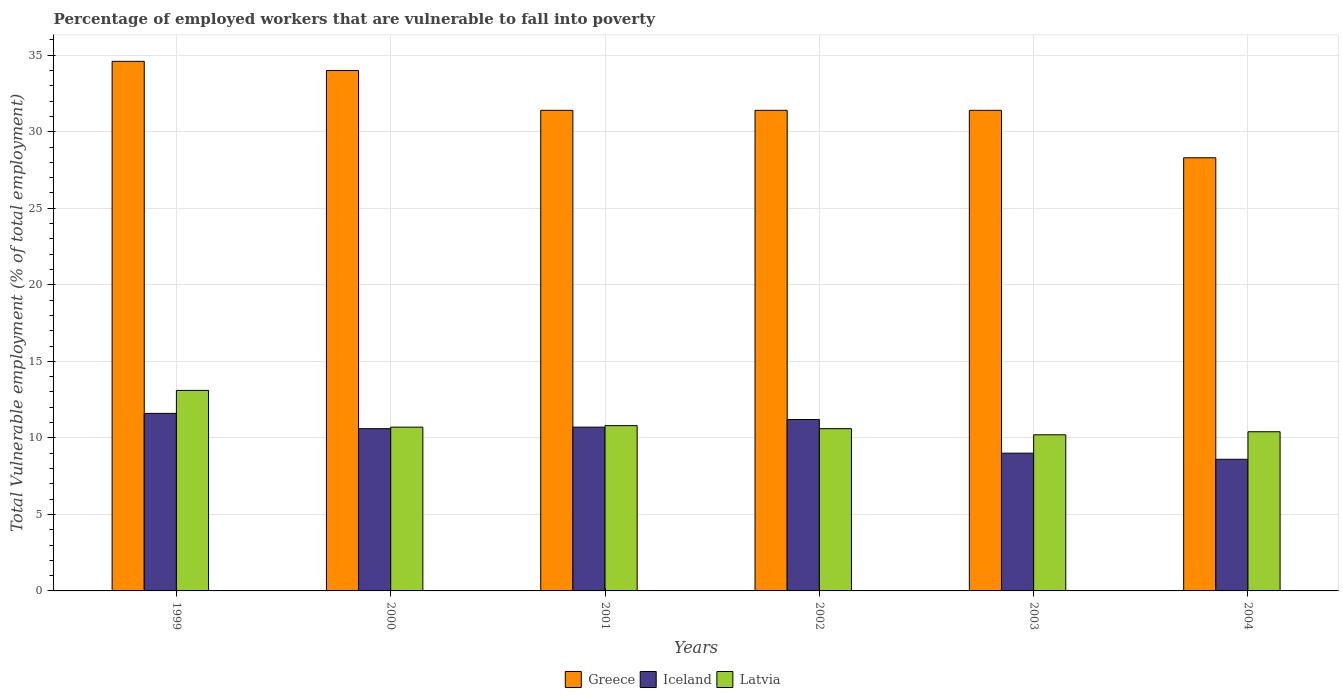How many different coloured bars are there?
Provide a succinct answer. 3. Are the number of bars per tick equal to the number of legend labels?
Ensure brevity in your answer.  Yes. Are the number of bars on each tick of the X-axis equal?
Give a very brief answer. Yes. How many bars are there on the 4th tick from the left?
Ensure brevity in your answer.  3. How many bars are there on the 1st tick from the right?
Your response must be concise. 3. What is the percentage of employed workers who are vulnerable to fall into poverty in Greece in 2001?
Your answer should be very brief. 31.4. Across all years, what is the maximum percentage of employed workers who are vulnerable to fall into poverty in Iceland?
Make the answer very short. 11.6. Across all years, what is the minimum percentage of employed workers who are vulnerable to fall into poverty in Latvia?
Make the answer very short. 10.2. In which year was the percentage of employed workers who are vulnerable to fall into poverty in Latvia maximum?
Provide a short and direct response. 1999. What is the total percentage of employed workers who are vulnerable to fall into poverty in Iceland in the graph?
Ensure brevity in your answer.  61.7. What is the difference between the percentage of employed workers who are vulnerable to fall into poverty in Greece in 2000 and that in 2002?
Your answer should be compact. 2.6. What is the difference between the percentage of employed workers who are vulnerable to fall into poverty in Iceland in 2001 and the percentage of employed workers who are vulnerable to fall into poverty in Latvia in 2004?
Offer a terse response. 0.3. What is the average percentage of employed workers who are vulnerable to fall into poverty in Greece per year?
Your answer should be compact. 31.85. In the year 2002, what is the difference between the percentage of employed workers who are vulnerable to fall into poverty in Latvia and percentage of employed workers who are vulnerable to fall into poverty in Iceland?
Provide a short and direct response. -0.6. What is the ratio of the percentage of employed workers who are vulnerable to fall into poverty in Iceland in 2000 to that in 2004?
Keep it short and to the point. 1.23. Is the percentage of employed workers who are vulnerable to fall into poverty in Greece in 2000 less than that in 2001?
Provide a short and direct response. No. Is the difference between the percentage of employed workers who are vulnerable to fall into poverty in Latvia in 2000 and 2003 greater than the difference between the percentage of employed workers who are vulnerable to fall into poverty in Iceland in 2000 and 2003?
Ensure brevity in your answer.  No. What is the difference between the highest and the second highest percentage of employed workers who are vulnerable to fall into poverty in Greece?
Make the answer very short. 0.6. What is the difference between the highest and the lowest percentage of employed workers who are vulnerable to fall into poverty in Greece?
Make the answer very short. 6.3. In how many years, is the percentage of employed workers who are vulnerable to fall into poverty in Greece greater than the average percentage of employed workers who are vulnerable to fall into poverty in Greece taken over all years?
Ensure brevity in your answer.  2. What does the 1st bar from the right in 2004 represents?
Ensure brevity in your answer.  Latvia. Is it the case that in every year, the sum of the percentage of employed workers who are vulnerable to fall into poverty in Latvia and percentage of employed workers who are vulnerable to fall into poverty in Greece is greater than the percentage of employed workers who are vulnerable to fall into poverty in Iceland?
Provide a short and direct response. Yes. What is the difference between two consecutive major ticks on the Y-axis?
Make the answer very short. 5. Does the graph contain grids?
Your answer should be very brief. Yes. What is the title of the graph?
Ensure brevity in your answer.  Percentage of employed workers that are vulnerable to fall into poverty. Does "Croatia" appear as one of the legend labels in the graph?
Your answer should be very brief. No. What is the label or title of the X-axis?
Provide a short and direct response. Years. What is the label or title of the Y-axis?
Provide a short and direct response. Total Vulnerable employment (% of total employment). What is the Total Vulnerable employment (% of total employment) of Greece in 1999?
Offer a terse response. 34.6. What is the Total Vulnerable employment (% of total employment) in Iceland in 1999?
Your answer should be compact. 11.6. What is the Total Vulnerable employment (% of total employment) of Latvia in 1999?
Your answer should be very brief. 13.1. What is the Total Vulnerable employment (% of total employment) in Iceland in 2000?
Your answer should be very brief. 10.6. What is the Total Vulnerable employment (% of total employment) of Latvia in 2000?
Provide a short and direct response. 10.7. What is the Total Vulnerable employment (% of total employment) of Greece in 2001?
Ensure brevity in your answer.  31.4. What is the Total Vulnerable employment (% of total employment) in Iceland in 2001?
Your answer should be compact. 10.7. What is the Total Vulnerable employment (% of total employment) in Latvia in 2001?
Ensure brevity in your answer.  10.8. What is the Total Vulnerable employment (% of total employment) of Greece in 2002?
Provide a short and direct response. 31.4. What is the Total Vulnerable employment (% of total employment) of Iceland in 2002?
Your response must be concise. 11.2. What is the Total Vulnerable employment (% of total employment) in Latvia in 2002?
Your response must be concise. 10.6. What is the Total Vulnerable employment (% of total employment) in Greece in 2003?
Keep it short and to the point. 31.4. What is the Total Vulnerable employment (% of total employment) in Latvia in 2003?
Provide a succinct answer. 10.2. What is the Total Vulnerable employment (% of total employment) in Greece in 2004?
Your answer should be compact. 28.3. What is the Total Vulnerable employment (% of total employment) in Iceland in 2004?
Your answer should be compact. 8.6. What is the Total Vulnerable employment (% of total employment) of Latvia in 2004?
Your answer should be compact. 10.4. Across all years, what is the maximum Total Vulnerable employment (% of total employment) in Greece?
Your answer should be very brief. 34.6. Across all years, what is the maximum Total Vulnerable employment (% of total employment) in Iceland?
Offer a terse response. 11.6. Across all years, what is the maximum Total Vulnerable employment (% of total employment) of Latvia?
Your answer should be compact. 13.1. Across all years, what is the minimum Total Vulnerable employment (% of total employment) in Greece?
Ensure brevity in your answer.  28.3. Across all years, what is the minimum Total Vulnerable employment (% of total employment) of Iceland?
Provide a succinct answer. 8.6. Across all years, what is the minimum Total Vulnerable employment (% of total employment) in Latvia?
Offer a terse response. 10.2. What is the total Total Vulnerable employment (% of total employment) in Greece in the graph?
Your answer should be very brief. 191.1. What is the total Total Vulnerable employment (% of total employment) of Iceland in the graph?
Keep it short and to the point. 61.7. What is the total Total Vulnerable employment (% of total employment) of Latvia in the graph?
Offer a terse response. 65.8. What is the difference between the Total Vulnerable employment (% of total employment) in Iceland in 1999 and that in 2000?
Offer a terse response. 1. What is the difference between the Total Vulnerable employment (% of total employment) in Latvia in 1999 and that in 2000?
Your response must be concise. 2.4. What is the difference between the Total Vulnerable employment (% of total employment) of Greece in 1999 and that in 2002?
Provide a succinct answer. 3.2. What is the difference between the Total Vulnerable employment (% of total employment) in Iceland in 1999 and that in 2002?
Offer a terse response. 0.4. What is the difference between the Total Vulnerable employment (% of total employment) of Iceland in 1999 and that in 2003?
Offer a very short reply. 2.6. What is the difference between the Total Vulnerable employment (% of total employment) in Greece in 1999 and that in 2004?
Provide a succinct answer. 6.3. What is the difference between the Total Vulnerable employment (% of total employment) of Iceland in 1999 and that in 2004?
Make the answer very short. 3. What is the difference between the Total Vulnerable employment (% of total employment) in Greece in 2000 and that in 2001?
Offer a very short reply. 2.6. What is the difference between the Total Vulnerable employment (% of total employment) in Greece in 2000 and that in 2002?
Offer a very short reply. 2.6. What is the difference between the Total Vulnerable employment (% of total employment) of Iceland in 2000 and that in 2002?
Make the answer very short. -0.6. What is the difference between the Total Vulnerable employment (% of total employment) of Latvia in 2000 and that in 2002?
Keep it short and to the point. 0.1. What is the difference between the Total Vulnerable employment (% of total employment) of Greece in 2000 and that in 2003?
Your answer should be very brief. 2.6. What is the difference between the Total Vulnerable employment (% of total employment) in Iceland in 2000 and that in 2003?
Provide a short and direct response. 1.6. What is the difference between the Total Vulnerable employment (% of total employment) in Latvia in 2000 and that in 2003?
Make the answer very short. 0.5. What is the difference between the Total Vulnerable employment (% of total employment) in Greece in 2001 and that in 2002?
Keep it short and to the point. 0. What is the difference between the Total Vulnerable employment (% of total employment) of Iceland in 2001 and that in 2002?
Offer a terse response. -0.5. What is the difference between the Total Vulnerable employment (% of total employment) of Greece in 2001 and that in 2003?
Provide a succinct answer. 0. What is the difference between the Total Vulnerable employment (% of total employment) of Iceland in 2001 and that in 2003?
Your response must be concise. 1.7. What is the difference between the Total Vulnerable employment (% of total employment) in Latvia in 2001 and that in 2003?
Your answer should be compact. 0.6. What is the difference between the Total Vulnerable employment (% of total employment) of Greece in 2001 and that in 2004?
Give a very brief answer. 3.1. What is the difference between the Total Vulnerable employment (% of total employment) of Iceland in 2001 and that in 2004?
Ensure brevity in your answer.  2.1. What is the difference between the Total Vulnerable employment (% of total employment) in Greece in 2002 and that in 2003?
Offer a very short reply. 0. What is the difference between the Total Vulnerable employment (% of total employment) of Iceland in 2002 and that in 2003?
Offer a terse response. 2.2. What is the difference between the Total Vulnerable employment (% of total employment) in Latvia in 2002 and that in 2003?
Give a very brief answer. 0.4. What is the difference between the Total Vulnerable employment (% of total employment) in Greece in 2002 and that in 2004?
Provide a short and direct response. 3.1. What is the difference between the Total Vulnerable employment (% of total employment) of Iceland in 2002 and that in 2004?
Provide a succinct answer. 2.6. What is the difference between the Total Vulnerable employment (% of total employment) of Latvia in 2002 and that in 2004?
Your response must be concise. 0.2. What is the difference between the Total Vulnerable employment (% of total employment) of Iceland in 2003 and that in 2004?
Provide a succinct answer. 0.4. What is the difference between the Total Vulnerable employment (% of total employment) in Latvia in 2003 and that in 2004?
Your response must be concise. -0.2. What is the difference between the Total Vulnerable employment (% of total employment) of Greece in 1999 and the Total Vulnerable employment (% of total employment) of Latvia in 2000?
Offer a terse response. 23.9. What is the difference between the Total Vulnerable employment (% of total employment) of Greece in 1999 and the Total Vulnerable employment (% of total employment) of Iceland in 2001?
Keep it short and to the point. 23.9. What is the difference between the Total Vulnerable employment (% of total employment) in Greece in 1999 and the Total Vulnerable employment (% of total employment) in Latvia in 2001?
Keep it short and to the point. 23.8. What is the difference between the Total Vulnerable employment (% of total employment) in Iceland in 1999 and the Total Vulnerable employment (% of total employment) in Latvia in 2001?
Give a very brief answer. 0.8. What is the difference between the Total Vulnerable employment (% of total employment) in Greece in 1999 and the Total Vulnerable employment (% of total employment) in Iceland in 2002?
Provide a succinct answer. 23.4. What is the difference between the Total Vulnerable employment (% of total employment) in Greece in 1999 and the Total Vulnerable employment (% of total employment) in Latvia in 2002?
Provide a short and direct response. 24. What is the difference between the Total Vulnerable employment (% of total employment) in Greece in 1999 and the Total Vulnerable employment (% of total employment) in Iceland in 2003?
Provide a short and direct response. 25.6. What is the difference between the Total Vulnerable employment (% of total employment) of Greece in 1999 and the Total Vulnerable employment (% of total employment) of Latvia in 2003?
Offer a terse response. 24.4. What is the difference between the Total Vulnerable employment (% of total employment) in Iceland in 1999 and the Total Vulnerable employment (% of total employment) in Latvia in 2003?
Give a very brief answer. 1.4. What is the difference between the Total Vulnerable employment (% of total employment) in Greece in 1999 and the Total Vulnerable employment (% of total employment) in Iceland in 2004?
Your answer should be very brief. 26. What is the difference between the Total Vulnerable employment (% of total employment) in Greece in 1999 and the Total Vulnerable employment (% of total employment) in Latvia in 2004?
Your answer should be very brief. 24.2. What is the difference between the Total Vulnerable employment (% of total employment) in Greece in 2000 and the Total Vulnerable employment (% of total employment) in Iceland in 2001?
Make the answer very short. 23.3. What is the difference between the Total Vulnerable employment (% of total employment) in Greece in 2000 and the Total Vulnerable employment (% of total employment) in Latvia in 2001?
Your answer should be very brief. 23.2. What is the difference between the Total Vulnerable employment (% of total employment) in Iceland in 2000 and the Total Vulnerable employment (% of total employment) in Latvia in 2001?
Your answer should be very brief. -0.2. What is the difference between the Total Vulnerable employment (% of total employment) in Greece in 2000 and the Total Vulnerable employment (% of total employment) in Iceland in 2002?
Offer a very short reply. 22.8. What is the difference between the Total Vulnerable employment (% of total employment) in Greece in 2000 and the Total Vulnerable employment (% of total employment) in Latvia in 2002?
Keep it short and to the point. 23.4. What is the difference between the Total Vulnerable employment (% of total employment) in Greece in 2000 and the Total Vulnerable employment (% of total employment) in Latvia in 2003?
Provide a short and direct response. 23.8. What is the difference between the Total Vulnerable employment (% of total employment) of Iceland in 2000 and the Total Vulnerable employment (% of total employment) of Latvia in 2003?
Offer a very short reply. 0.4. What is the difference between the Total Vulnerable employment (% of total employment) of Greece in 2000 and the Total Vulnerable employment (% of total employment) of Iceland in 2004?
Your answer should be very brief. 25.4. What is the difference between the Total Vulnerable employment (% of total employment) of Greece in 2000 and the Total Vulnerable employment (% of total employment) of Latvia in 2004?
Keep it short and to the point. 23.6. What is the difference between the Total Vulnerable employment (% of total employment) of Iceland in 2000 and the Total Vulnerable employment (% of total employment) of Latvia in 2004?
Ensure brevity in your answer.  0.2. What is the difference between the Total Vulnerable employment (% of total employment) in Greece in 2001 and the Total Vulnerable employment (% of total employment) in Iceland in 2002?
Your answer should be compact. 20.2. What is the difference between the Total Vulnerable employment (% of total employment) of Greece in 2001 and the Total Vulnerable employment (% of total employment) of Latvia in 2002?
Offer a terse response. 20.8. What is the difference between the Total Vulnerable employment (% of total employment) in Greece in 2001 and the Total Vulnerable employment (% of total employment) in Iceland in 2003?
Provide a short and direct response. 22.4. What is the difference between the Total Vulnerable employment (% of total employment) in Greece in 2001 and the Total Vulnerable employment (% of total employment) in Latvia in 2003?
Your answer should be very brief. 21.2. What is the difference between the Total Vulnerable employment (% of total employment) of Iceland in 2001 and the Total Vulnerable employment (% of total employment) of Latvia in 2003?
Provide a short and direct response. 0.5. What is the difference between the Total Vulnerable employment (% of total employment) in Greece in 2001 and the Total Vulnerable employment (% of total employment) in Iceland in 2004?
Provide a succinct answer. 22.8. What is the difference between the Total Vulnerable employment (% of total employment) of Greece in 2002 and the Total Vulnerable employment (% of total employment) of Iceland in 2003?
Your response must be concise. 22.4. What is the difference between the Total Vulnerable employment (% of total employment) of Greece in 2002 and the Total Vulnerable employment (% of total employment) of Latvia in 2003?
Provide a short and direct response. 21.2. What is the difference between the Total Vulnerable employment (% of total employment) of Greece in 2002 and the Total Vulnerable employment (% of total employment) of Iceland in 2004?
Your answer should be compact. 22.8. What is the difference between the Total Vulnerable employment (% of total employment) of Greece in 2002 and the Total Vulnerable employment (% of total employment) of Latvia in 2004?
Keep it short and to the point. 21. What is the difference between the Total Vulnerable employment (% of total employment) of Iceland in 2002 and the Total Vulnerable employment (% of total employment) of Latvia in 2004?
Your answer should be very brief. 0.8. What is the difference between the Total Vulnerable employment (% of total employment) of Greece in 2003 and the Total Vulnerable employment (% of total employment) of Iceland in 2004?
Provide a short and direct response. 22.8. What is the difference between the Total Vulnerable employment (% of total employment) in Greece in 2003 and the Total Vulnerable employment (% of total employment) in Latvia in 2004?
Offer a very short reply. 21. What is the difference between the Total Vulnerable employment (% of total employment) of Iceland in 2003 and the Total Vulnerable employment (% of total employment) of Latvia in 2004?
Offer a very short reply. -1.4. What is the average Total Vulnerable employment (% of total employment) of Greece per year?
Offer a terse response. 31.85. What is the average Total Vulnerable employment (% of total employment) in Iceland per year?
Provide a succinct answer. 10.28. What is the average Total Vulnerable employment (% of total employment) of Latvia per year?
Make the answer very short. 10.97. In the year 1999, what is the difference between the Total Vulnerable employment (% of total employment) in Greece and Total Vulnerable employment (% of total employment) in Latvia?
Keep it short and to the point. 21.5. In the year 1999, what is the difference between the Total Vulnerable employment (% of total employment) in Iceland and Total Vulnerable employment (% of total employment) in Latvia?
Offer a very short reply. -1.5. In the year 2000, what is the difference between the Total Vulnerable employment (% of total employment) of Greece and Total Vulnerable employment (% of total employment) of Iceland?
Your answer should be compact. 23.4. In the year 2000, what is the difference between the Total Vulnerable employment (% of total employment) in Greece and Total Vulnerable employment (% of total employment) in Latvia?
Your answer should be very brief. 23.3. In the year 2001, what is the difference between the Total Vulnerable employment (% of total employment) in Greece and Total Vulnerable employment (% of total employment) in Iceland?
Make the answer very short. 20.7. In the year 2001, what is the difference between the Total Vulnerable employment (% of total employment) of Greece and Total Vulnerable employment (% of total employment) of Latvia?
Your answer should be very brief. 20.6. In the year 2001, what is the difference between the Total Vulnerable employment (% of total employment) of Iceland and Total Vulnerable employment (% of total employment) of Latvia?
Provide a succinct answer. -0.1. In the year 2002, what is the difference between the Total Vulnerable employment (% of total employment) in Greece and Total Vulnerable employment (% of total employment) in Iceland?
Provide a short and direct response. 20.2. In the year 2002, what is the difference between the Total Vulnerable employment (% of total employment) of Greece and Total Vulnerable employment (% of total employment) of Latvia?
Offer a terse response. 20.8. In the year 2003, what is the difference between the Total Vulnerable employment (% of total employment) of Greece and Total Vulnerable employment (% of total employment) of Iceland?
Make the answer very short. 22.4. In the year 2003, what is the difference between the Total Vulnerable employment (% of total employment) in Greece and Total Vulnerable employment (% of total employment) in Latvia?
Offer a terse response. 21.2. In the year 2003, what is the difference between the Total Vulnerable employment (% of total employment) in Iceland and Total Vulnerable employment (% of total employment) in Latvia?
Your answer should be compact. -1.2. In the year 2004, what is the difference between the Total Vulnerable employment (% of total employment) in Greece and Total Vulnerable employment (% of total employment) in Iceland?
Offer a very short reply. 19.7. In the year 2004, what is the difference between the Total Vulnerable employment (% of total employment) in Greece and Total Vulnerable employment (% of total employment) in Latvia?
Your answer should be very brief. 17.9. In the year 2004, what is the difference between the Total Vulnerable employment (% of total employment) in Iceland and Total Vulnerable employment (% of total employment) in Latvia?
Offer a terse response. -1.8. What is the ratio of the Total Vulnerable employment (% of total employment) in Greece in 1999 to that in 2000?
Your answer should be very brief. 1.02. What is the ratio of the Total Vulnerable employment (% of total employment) in Iceland in 1999 to that in 2000?
Ensure brevity in your answer.  1.09. What is the ratio of the Total Vulnerable employment (% of total employment) of Latvia in 1999 to that in 2000?
Your answer should be very brief. 1.22. What is the ratio of the Total Vulnerable employment (% of total employment) in Greece in 1999 to that in 2001?
Offer a terse response. 1.1. What is the ratio of the Total Vulnerable employment (% of total employment) of Iceland in 1999 to that in 2001?
Offer a very short reply. 1.08. What is the ratio of the Total Vulnerable employment (% of total employment) of Latvia in 1999 to that in 2001?
Give a very brief answer. 1.21. What is the ratio of the Total Vulnerable employment (% of total employment) of Greece in 1999 to that in 2002?
Keep it short and to the point. 1.1. What is the ratio of the Total Vulnerable employment (% of total employment) of Iceland in 1999 to that in 2002?
Keep it short and to the point. 1.04. What is the ratio of the Total Vulnerable employment (% of total employment) of Latvia in 1999 to that in 2002?
Your answer should be very brief. 1.24. What is the ratio of the Total Vulnerable employment (% of total employment) of Greece in 1999 to that in 2003?
Offer a very short reply. 1.1. What is the ratio of the Total Vulnerable employment (% of total employment) in Iceland in 1999 to that in 2003?
Your answer should be compact. 1.29. What is the ratio of the Total Vulnerable employment (% of total employment) in Latvia in 1999 to that in 2003?
Your answer should be very brief. 1.28. What is the ratio of the Total Vulnerable employment (% of total employment) in Greece in 1999 to that in 2004?
Your response must be concise. 1.22. What is the ratio of the Total Vulnerable employment (% of total employment) of Iceland in 1999 to that in 2004?
Keep it short and to the point. 1.35. What is the ratio of the Total Vulnerable employment (% of total employment) of Latvia in 1999 to that in 2004?
Your answer should be very brief. 1.26. What is the ratio of the Total Vulnerable employment (% of total employment) of Greece in 2000 to that in 2001?
Your answer should be very brief. 1.08. What is the ratio of the Total Vulnerable employment (% of total employment) of Greece in 2000 to that in 2002?
Give a very brief answer. 1.08. What is the ratio of the Total Vulnerable employment (% of total employment) of Iceland in 2000 to that in 2002?
Offer a very short reply. 0.95. What is the ratio of the Total Vulnerable employment (% of total employment) of Latvia in 2000 to that in 2002?
Your answer should be compact. 1.01. What is the ratio of the Total Vulnerable employment (% of total employment) of Greece in 2000 to that in 2003?
Provide a short and direct response. 1.08. What is the ratio of the Total Vulnerable employment (% of total employment) of Iceland in 2000 to that in 2003?
Offer a very short reply. 1.18. What is the ratio of the Total Vulnerable employment (% of total employment) in Latvia in 2000 to that in 2003?
Provide a succinct answer. 1.05. What is the ratio of the Total Vulnerable employment (% of total employment) of Greece in 2000 to that in 2004?
Provide a succinct answer. 1.2. What is the ratio of the Total Vulnerable employment (% of total employment) in Iceland in 2000 to that in 2004?
Provide a succinct answer. 1.23. What is the ratio of the Total Vulnerable employment (% of total employment) of Latvia in 2000 to that in 2004?
Give a very brief answer. 1.03. What is the ratio of the Total Vulnerable employment (% of total employment) in Greece in 2001 to that in 2002?
Keep it short and to the point. 1. What is the ratio of the Total Vulnerable employment (% of total employment) of Iceland in 2001 to that in 2002?
Provide a short and direct response. 0.96. What is the ratio of the Total Vulnerable employment (% of total employment) of Latvia in 2001 to that in 2002?
Provide a succinct answer. 1.02. What is the ratio of the Total Vulnerable employment (% of total employment) in Greece in 2001 to that in 2003?
Provide a short and direct response. 1. What is the ratio of the Total Vulnerable employment (% of total employment) in Iceland in 2001 to that in 2003?
Offer a very short reply. 1.19. What is the ratio of the Total Vulnerable employment (% of total employment) of Latvia in 2001 to that in 2003?
Ensure brevity in your answer.  1.06. What is the ratio of the Total Vulnerable employment (% of total employment) in Greece in 2001 to that in 2004?
Offer a very short reply. 1.11. What is the ratio of the Total Vulnerable employment (% of total employment) in Iceland in 2001 to that in 2004?
Make the answer very short. 1.24. What is the ratio of the Total Vulnerable employment (% of total employment) of Iceland in 2002 to that in 2003?
Provide a succinct answer. 1.24. What is the ratio of the Total Vulnerable employment (% of total employment) of Latvia in 2002 to that in 2003?
Your response must be concise. 1.04. What is the ratio of the Total Vulnerable employment (% of total employment) of Greece in 2002 to that in 2004?
Your answer should be very brief. 1.11. What is the ratio of the Total Vulnerable employment (% of total employment) of Iceland in 2002 to that in 2004?
Ensure brevity in your answer.  1.3. What is the ratio of the Total Vulnerable employment (% of total employment) in Latvia in 2002 to that in 2004?
Give a very brief answer. 1.02. What is the ratio of the Total Vulnerable employment (% of total employment) of Greece in 2003 to that in 2004?
Keep it short and to the point. 1.11. What is the ratio of the Total Vulnerable employment (% of total employment) of Iceland in 2003 to that in 2004?
Your answer should be compact. 1.05. What is the ratio of the Total Vulnerable employment (% of total employment) of Latvia in 2003 to that in 2004?
Your response must be concise. 0.98. What is the difference between the highest and the second highest Total Vulnerable employment (% of total employment) of Latvia?
Ensure brevity in your answer.  2.3. What is the difference between the highest and the lowest Total Vulnerable employment (% of total employment) of Iceland?
Your answer should be compact. 3. What is the difference between the highest and the lowest Total Vulnerable employment (% of total employment) in Latvia?
Ensure brevity in your answer.  2.9. 